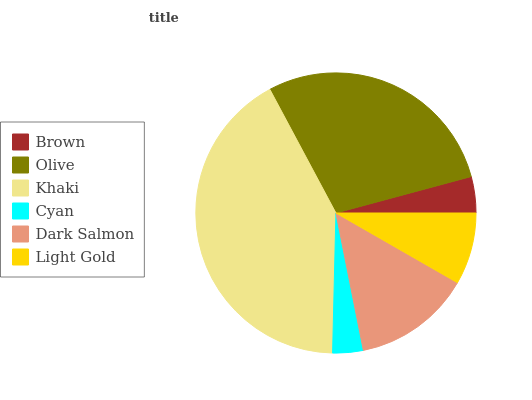Is Cyan the minimum?
Answer yes or no. Yes. Is Khaki the maximum?
Answer yes or no. Yes. Is Olive the minimum?
Answer yes or no. No. Is Olive the maximum?
Answer yes or no. No. Is Olive greater than Brown?
Answer yes or no. Yes. Is Brown less than Olive?
Answer yes or no. Yes. Is Brown greater than Olive?
Answer yes or no. No. Is Olive less than Brown?
Answer yes or no. No. Is Dark Salmon the high median?
Answer yes or no. Yes. Is Light Gold the low median?
Answer yes or no. Yes. Is Cyan the high median?
Answer yes or no. No. Is Cyan the low median?
Answer yes or no. No. 